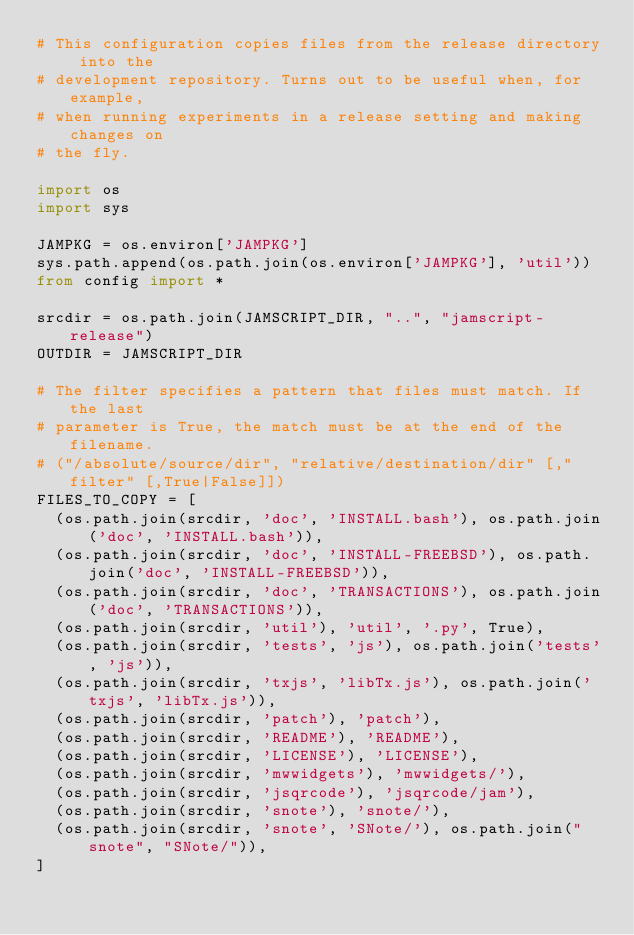<code> <loc_0><loc_0><loc_500><loc_500><_Python_># This configuration copies files from the release directory into the
# development repository. Turns out to be useful when, for example,
# when running experiments in a release setting and making changes on
# the fly.

import os
import sys

JAMPKG = os.environ['JAMPKG']
sys.path.append(os.path.join(os.environ['JAMPKG'], 'util'))
from config import *

srcdir = os.path.join(JAMSCRIPT_DIR, "..", "jamscript-release")
OUTDIR = JAMSCRIPT_DIR

# The filter specifies a pattern that files must match. If the last
# parameter is True, the match must be at the end of the filename.
# ("/absolute/source/dir", "relative/destination/dir" [,"filter" [,True|False]])
FILES_TO_COPY = [
  (os.path.join(srcdir, 'doc', 'INSTALL.bash'), os.path.join('doc', 'INSTALL.bash')),
  (os.path.join(srcdir, 'doc', 'INSTALL-FREEBSD'), os.path.join('doc', 'INSTALL-FREEBSD')),
  (os.path.join(srcdir, 'doc', 'TRANSACTIONS'), os.path.join('doc', 'TRANSACTIONS')),
  (os.path.join(srcdir, 'util'), 'util', '.py', True),
  (os.path.join(srcdir, 'tests', 'js'), os.path.join('tests', 'js')),
  (os.path.join(srcdir, 'txjs', 'libTx.js'), os.path.join('txjs', 'libTx.js')),
  (os.path.join(srcdir, 'patch'), 'patch'),
  (os.path.join(srcdir, 'README'), 'README'),
  (os.path.join(srcdir, 'LICENSE'), 'LICENSE'),
  (os.path.join(srcdir, 'mwwidgets'), 'mwwidgets/'),
  (os.path.join(srcdir, 'jsqrcode'), 'jsqrcode/jam'),
  (os.path.join(srcdir, 'snote'), 'snote/'),
  (os.path.join(srcdir, 'snote', 'SNote/'), os.path.join("snote", "SNote/")),
]


</code> 